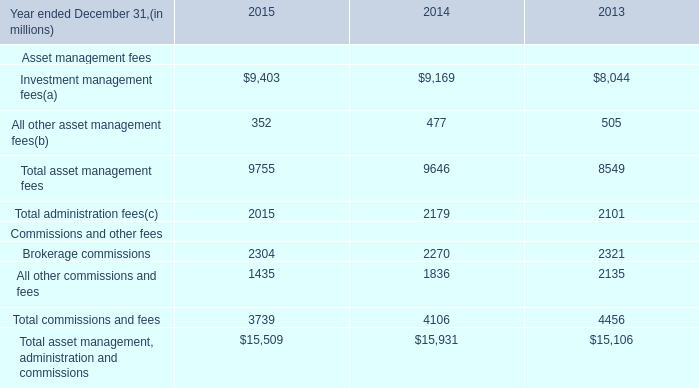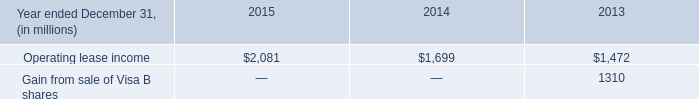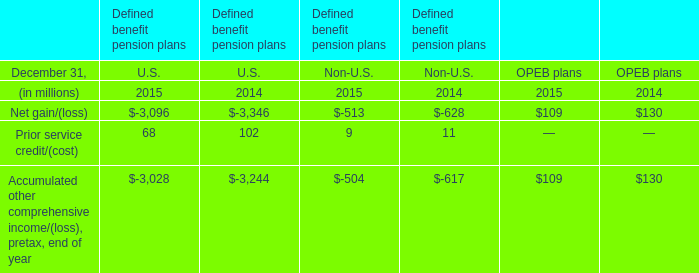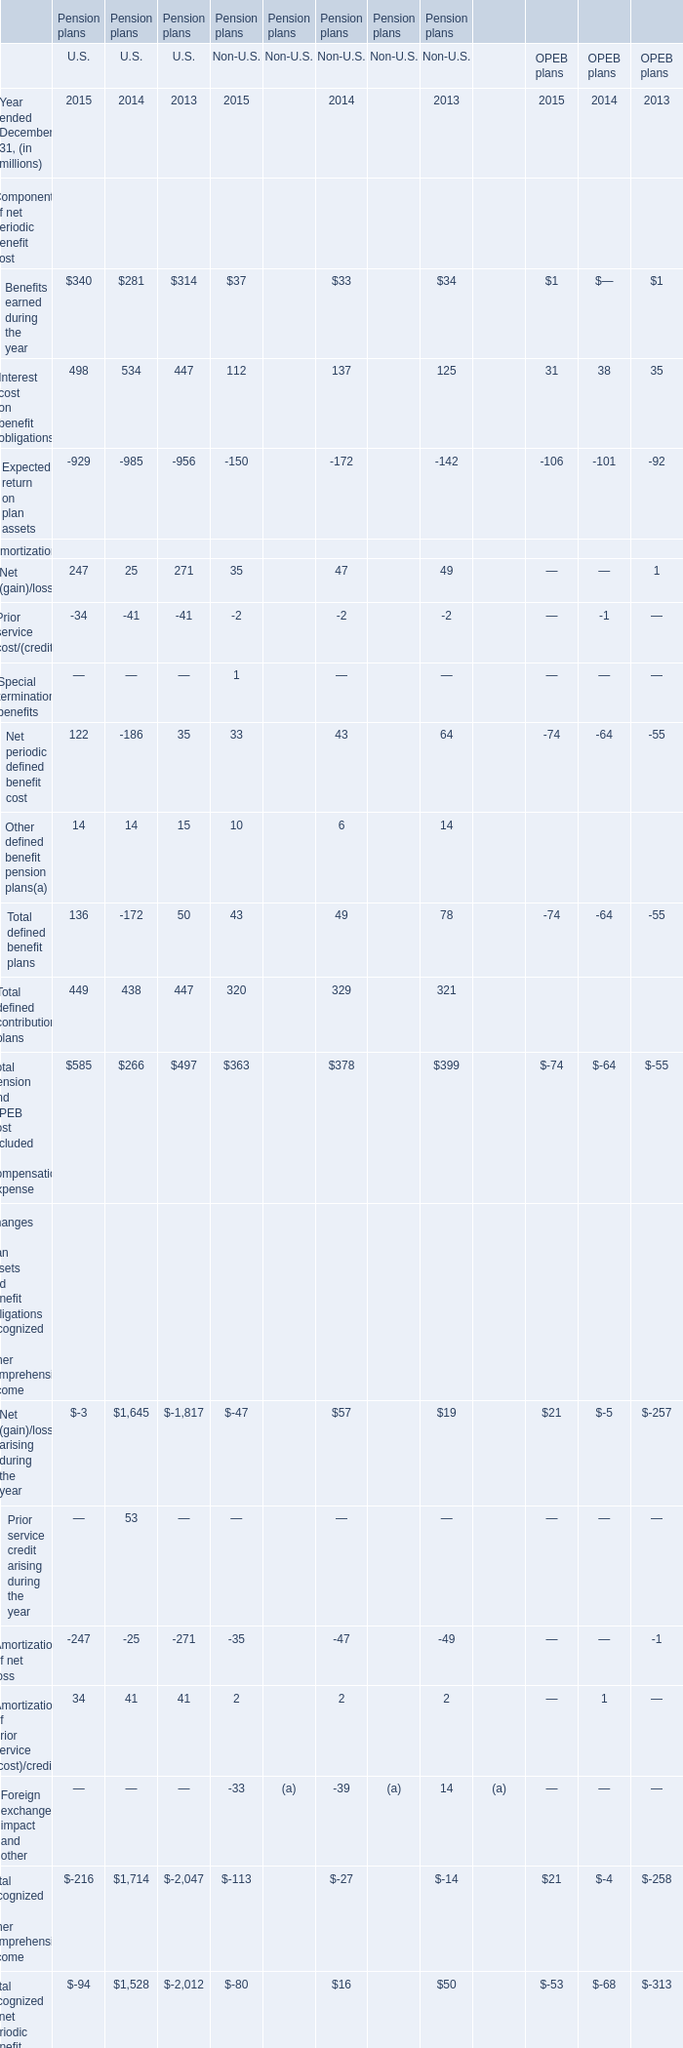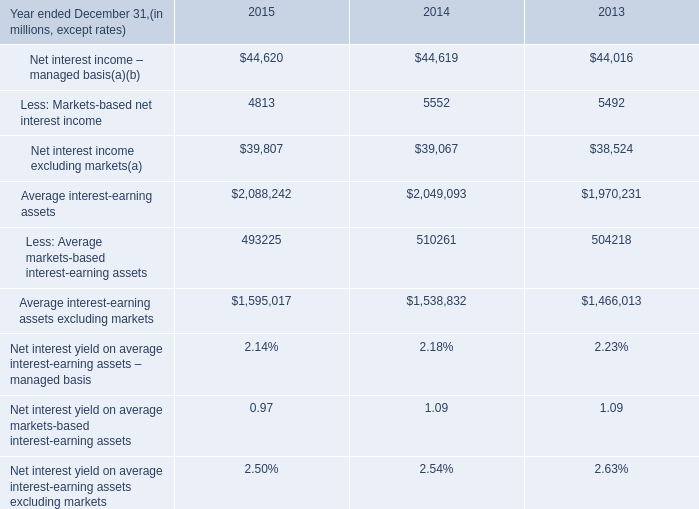What is the average amount of Net interest income excluding markets of 2015, and Gain from sale of Visa B shares of 2013 ? 
Computations: ((39807.0 + 1310.0) / 2)
Answer: 20558.5. 